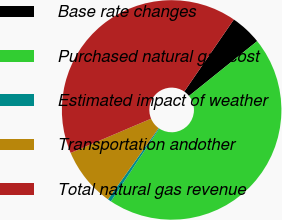Convert chart. <chart><loc_0><loc_0><loc_500><loc_500><pie_chart><fcel>Base rate changes<fcel>Purchased natural gas cost<fcel>Estimated impact of weather<fcel>Transportation andother<fcel>Total natural gas revenue<nl><fcel>4.63%<fcel>45.1%<fcel>0.52%<fcel>8.74%<fcel>40.99%<nl></chart> 